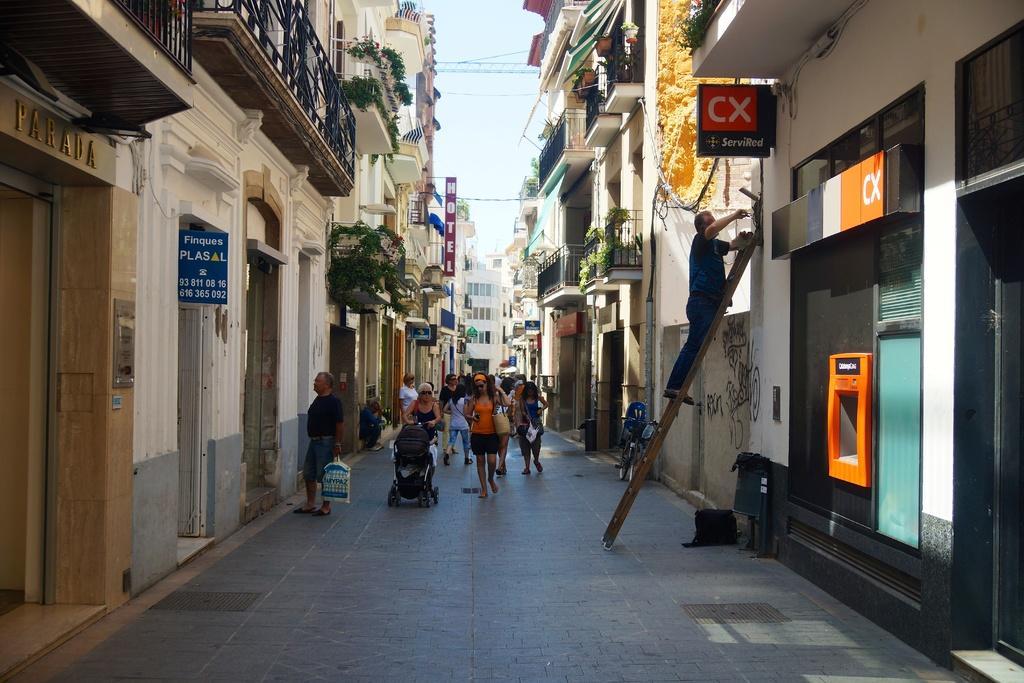Could you give a brief overview of what you see in this image? In this image we can see a group of people on the ground. In that a man is holding a cover and a woman is holding a trolley. On the right side we can see a man on a ladder and a bicycle parked aside. We can also see a group of buildings with windows, the railing, some plants, the sign boards with some text on them and the sky which looks cloudy. 